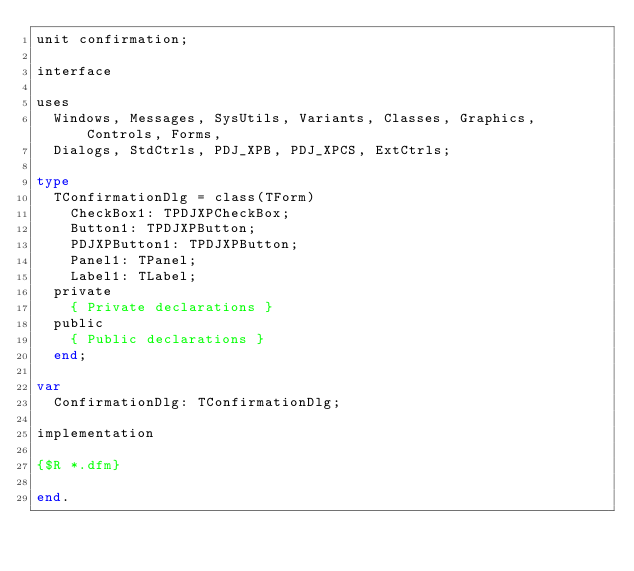Convert code to text. <code><loc_0><loc_0><loc_500><loc_500><_Pascal_>unit confirmation;

interface

uses
  Windows, Messages, SysUtils, Variants, Classes, Graphics, Controls, Forms,
  Dialogs, StdCtrls, PDJ_XPB, PDJ_XPCS, ExtCtrls;

type
  TConfirmationDlg = class(TForm)
    CheckBox1: TPDJXPCheckBox;
    Button1: TPDJXPButton;
    PDJXPButton1: TPDJXPButton;
    Panel1: TPanel;
    Label1: TLabel;
  private
    { Private declarations }
  public
    { Public declarations }
  end;

var
  ConfirmationDlg: TConfirmationDlg;

implementation

{$R *.dfm}

end.
</code> 